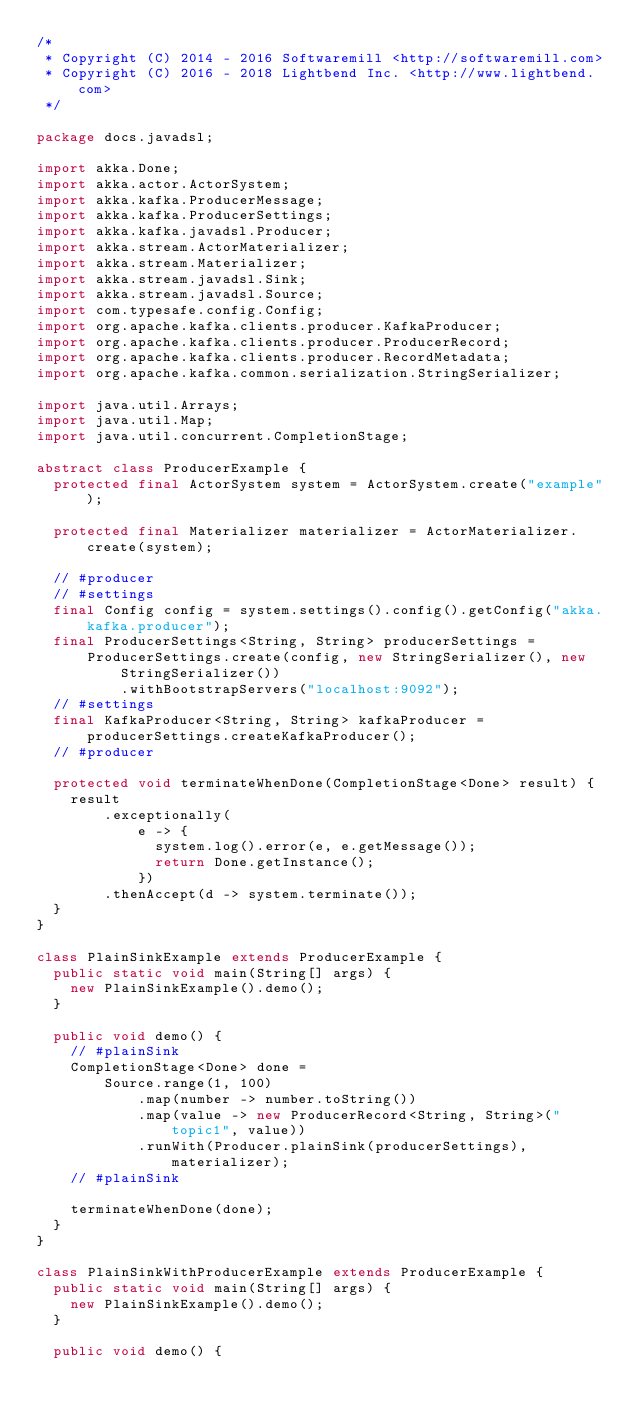Convert code to text. <code><loc_0><loc_0><loc_500><loc_500><_Java_>/*
 * Copyright (C) 2014 - 2016 Softwaremill <http://softwaremill.com>
 * Copyright (C) 2016 - 2018 Lightbend Inc. <http://www.lightbend.com>
 */

package docs.javadsl;

import akka.Done;
import akka.actor.ActorSystem;
import akka.kafka.ProducerMessage;
import akka.kafka.ProducerSettings;
import akka.kafka.javadsl.Producer;
import akka.stream.ActorMaterializer;
import akka.stream.Materializer;
import akka.stream.javadsl.Sink;
import akka.stream.javadsl.Source;
import com.typesafe.config.Config;
import org.apache.kafka.clients.producer.KafkaProducer;
import org.apache.kafka.clients.producer.ProducerRecord;
import org.apache.kafka.clients.producer.RecordMetadata;
import org.apache.kafka.common.serialization.StringSerializer;

import java.util.Arrays;
import java.util.Map;
import java.util.concurrent.CompletionStage;

abstract class ProducerExample {
  protected final ActorSystem system = ActorSystem.create("example");

  protected final Materializer materializer = ActorMaterializer.create(system);

  // #producer
  // #settings
  final Config config = system.settings().config().getConfig("akka.kafka.producer");
  final ProducerSettings<String, String> producerSettings =
      ProducerSettings.create(config, new StringSerializer(), new StringSerializer())
          .withBootstrapServers("localhost:9092");
  // #settings
  final KafkaProducer<String, String> kafkaProducer = producerSettings.createKafkaProducer();
  // #producer

  protected void terminateWhenDone(CompletionStage<Done> result) {
    result
        .exceptionally(
            e -> {
              system.log().error(e, e.getMessage());
              return Done.getInstance();
            })
        .thenAccept(d -> system.terminate());
  }
}

class PlainSinkExample extends ProducerExample {
  public static void main(String[] args) {
    new PlainSinkExample().demo();
  }

  public void demo() {
    // #plainSink
    CompletionStage<Done> done =
        Source.range(1, 100)
            .map(number -> number.toString())
            .map(value -> new ProducerRecord<String, String>("topic1", value))
            .runWith(Producer.plainSink(producerSettings), materializer);
    // #plainSink

    terminateWhenDone(done);
  }
}

class PlainSinkWithProducerExample extends ProducerExample {
  public static void main(String[] args) {
    new PlainSinkExample().demo();
  }

  public void demo() {</code> 